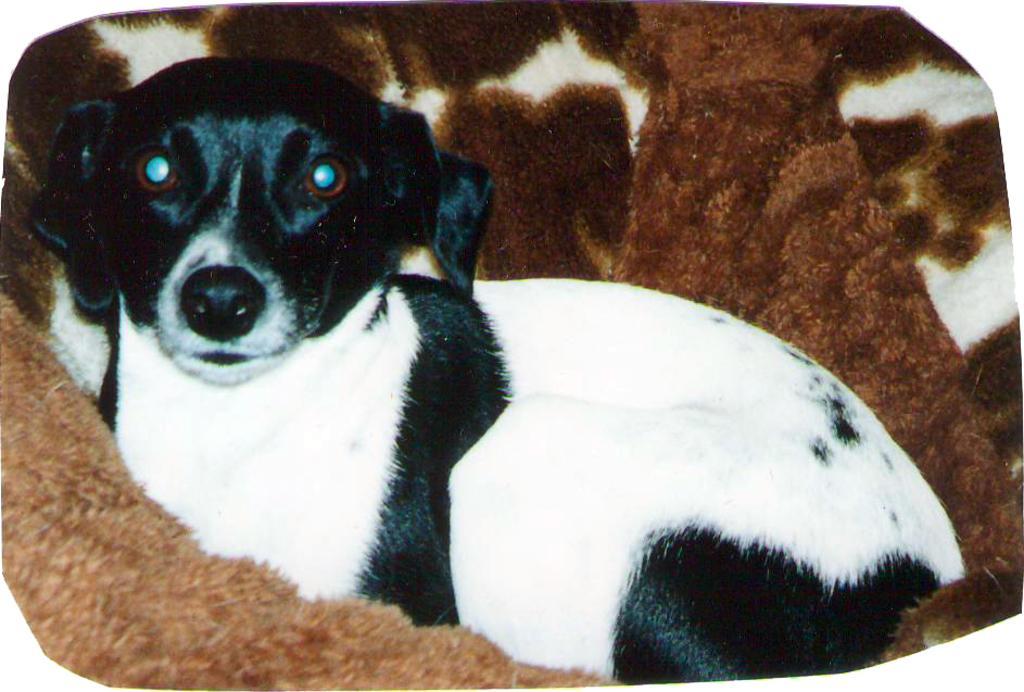Describe this image in one or two sentences. In the center of the image we can see a dog sitting on the couch. 